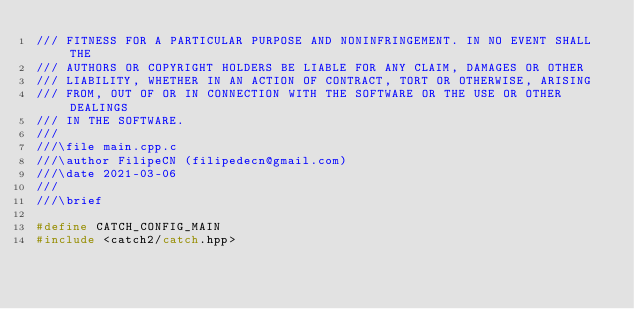<code> <loc_0><loc_0><loc_500><loc_500><_C++_>/// FITNESS FOR A PARTICULAR PURPOSE AND NONINFRINGEMENT. IN NO EVENT SHALL THE
/// AUTHORS OR COPYRIGHT HOLDERS BE LIABLE FOR ANY CLAIM, DAMAGES OR OTHER
/// LIABILITY, WHETHER IN AN ACTION OF CONTRACT, TORT OR OTHERWISE, ARISING
/// FROM, OUT OF OR IN CONNECTION WITH THE SOFTWARE OR THE USE OR OTHER DEALINGS
/// IN THE SOFTWARE.
///
///\file main.cpp.c
///\author FilipeCN (filipedecn@gmail.com)
///\date 2021-03-06
///
///\brief

#define CATCH_CONFIG_MAIN
#include <catch2/catch.hpp></code> 